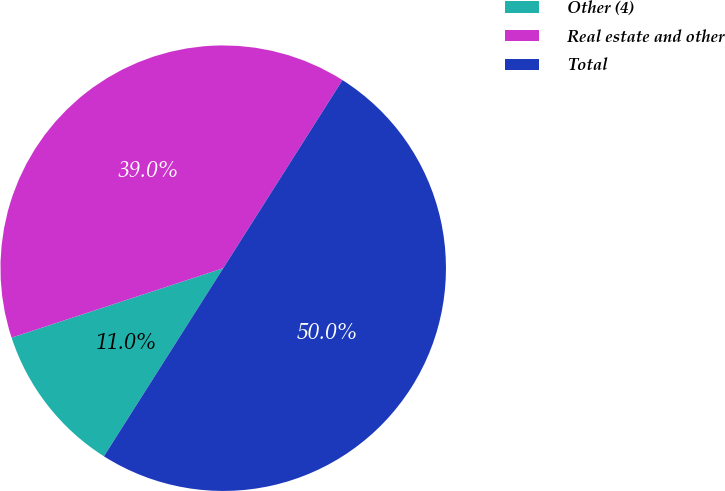Convert chart to OTSL. <chart><loc_0><loc_0><loc_500><loc_500><pie_chart><fcel>Other (4)<fcel>Real estate and other<fcel>Total<nl><fcel>10.96%<fcel>39.04%<fcel>50.0%<nl></chart> 